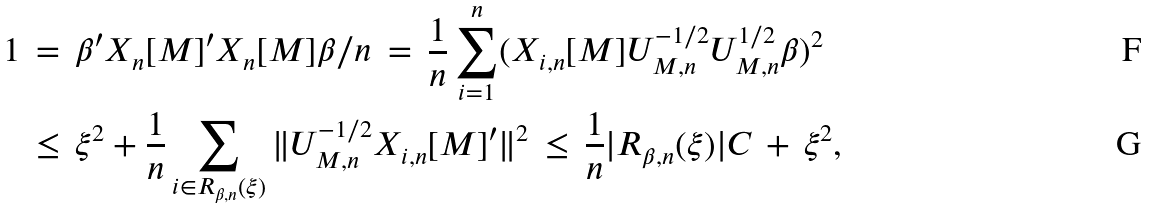Convert formula to latex. <formula><loc_0><loc_0><loc_500><loc_500>1 \, & = \, \beta ^ { \prime } X _ { n } [ M ] ^ { \prime } X _ { n } [ M ] \beta / n \, = \, \frac { 1 } { n } \sum _ { i = 1 } ^ { n } ( X _ { i , n } [ M ] U _ { M , n } ^ { - 1 / 2 } U _ { M , n } ^ { 1 / 2 } \beta ) ^ { 2 } \\ & \leq \, \xi ^ { 2 } + \frac { 1 } { n } \sum _ { i \in R _ { \beta , n } ( \xi ) } \| U _ { M , n } ^ { - 1 / 2 } X _ { i , n } [ M ] ^ { \prime } \| ^ { 2 } \, \leq \, \frac { 1 } { n } | R _ { \beta , n } ( \xi ) | C \, + \, \xi ^ { 2 } ,</formula> 